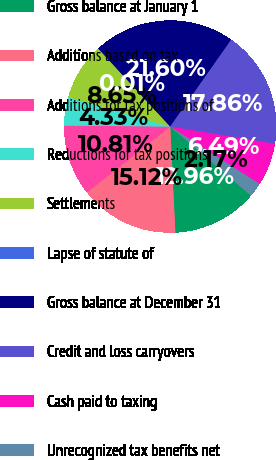Convert chart to OTSL. <chart><loc_0><loc_0><loc_500><loc_500><pie_chart><fcel>Gross balance at January 1<fcel>Additions based on tax<fcel>Additions for tax positions of<fcel>Reductions for tax positions<fcel>Settlements<fcel>Lapse of statute of<fcel>Gross balance at December 31<fcel>Credit and loss carryovers<fcel>Cash paid to taxing<fcel>Unrecognized tax benefits net<nl><fcel>12.97%<fcel>15.13%<fcel>10.81%<fcel>4.33%<fcel>8.65%<fcel>0.01%<fcel>21.61%<fcel>17.87%<fcel>6.49%<fcel>2.17%<nl></chart> 